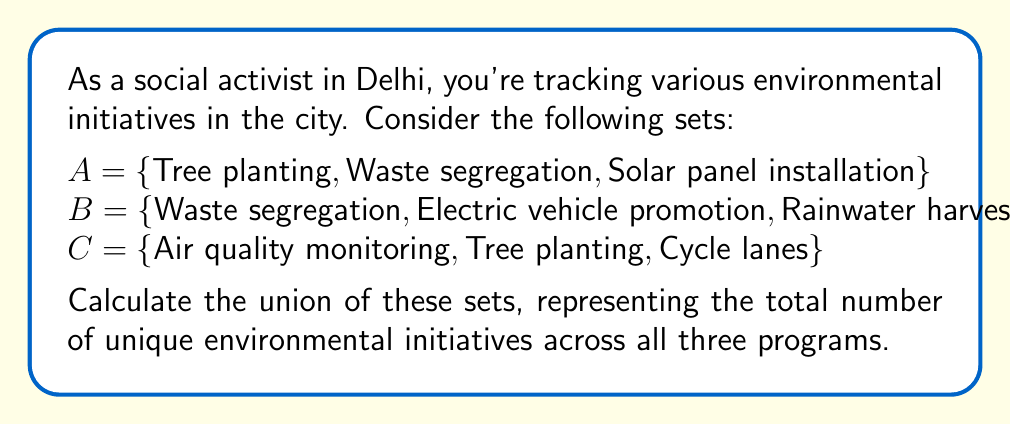Give your solution to this math problem. To solve this problem, we need to find the union of sets A, B, and C. The union of sets includes all unique elements from all sets, without repetition.

Let's follow these steps:

1. List all elements from set A:
   {Tree planting, Waste segregation, Solar panel installation}

2. Add unique elements from set B:
   Waste segregation is already included, so we add:
   {Electric vehicle promotion, Rainwater harvesting}

3. Add unique elements from set C:
   Tree planting is already included, so we add:
   {Air quality monitoring, Cycle lanes}

4. Count the total number of unique elements in the union:

   $A \cup B \cup C = \{$Tree planting, Waste segregation, Solar panel installation, Electric vehicle promotion, Rainwater harvesting, Air quality monitoring, Cycle lanes$\}$

   The number of elements in this set is 7.

We can represent this mathematically as:

$$|A \cup B \cup C| = 7$$

Where $|...|$ denotes the cardinality (number of elements) of the set.
Answer: $|A \cup B \cup C| = 7$ 